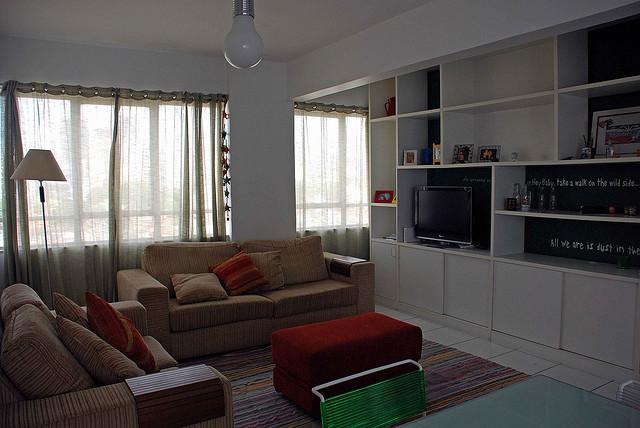Is the furniture modern?
Keep it brief. Yes. Is there a lamp in the room?
Give a very brief answer. Yes. Is the couch made of leather?
Answer briefly. No. Which light source is dominant, electric or natural?
Keep it brief. Natural. How many pillows are on the couches?
Keep it brief. 6. How many chairs are identical?
Quick response, please. 2. Does the room look cozy?
Quick response, please. Yes. What color is the ottoman?
Keep it brief. Red. Are the curtains hanging straight down?
Short answer required. Yes. Is there a curtain on the window?
Quick response, please. Yes. 